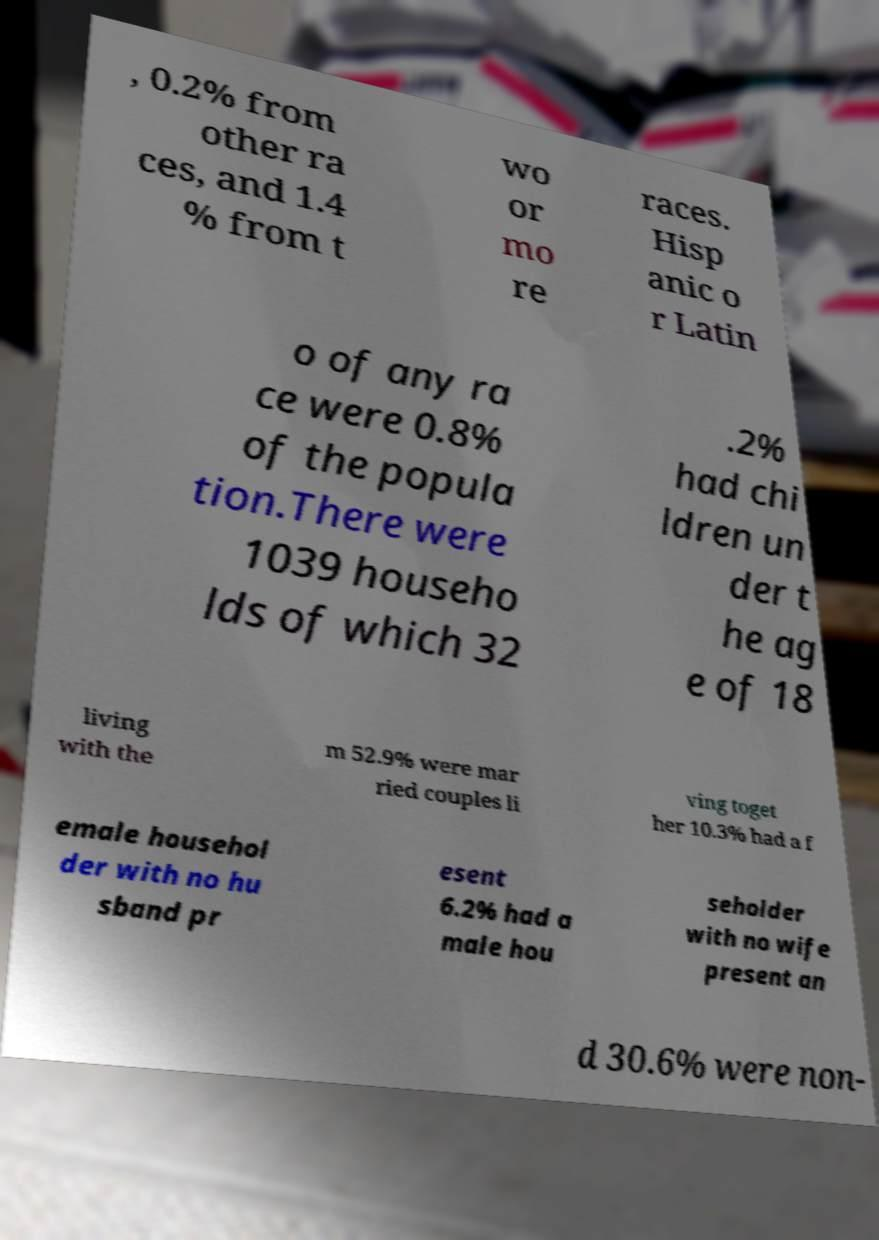Could you assist in decoding the text presented in this image and type it out clearly? , 0.2% from other ra ces, and 1.4 % from t wo or mo re races. Hisp anic o r Latin o of any ra ce were 0.8% of the popula tion.There were 1039 househo lds of which 32 .2% had chi ldren un der t he ag e of 18 living with the m 52.9% were mar ried couples li ving toget her 10.3% had a f emale househol der with no hu sband pr esent 6.2% had a male hou seholder with no wife present an d 30.6% were non- 